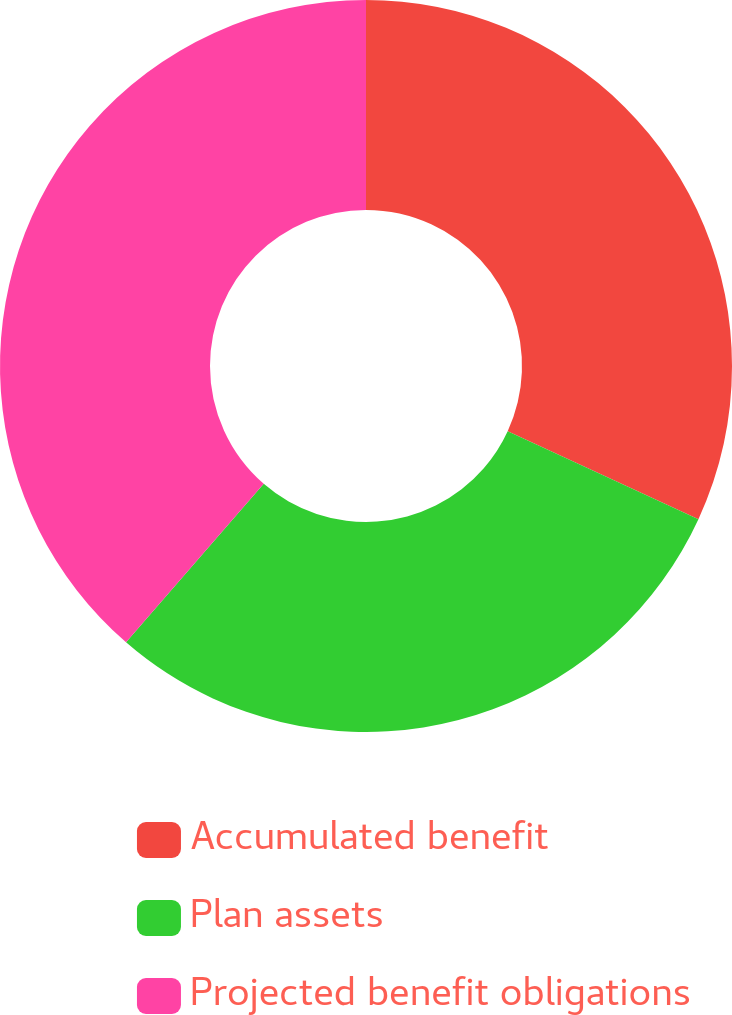Convert chart to OTSL. <chart><loc_0><loc_0><loc_500><loc_500><pie_chart><fcel>Accumulated benefit<fcel>Plan assets<fcel>Projected benefit obligations<nl><fcel>31.87%<fcel>29.51%<fcel>38.62%<nl></chart> 